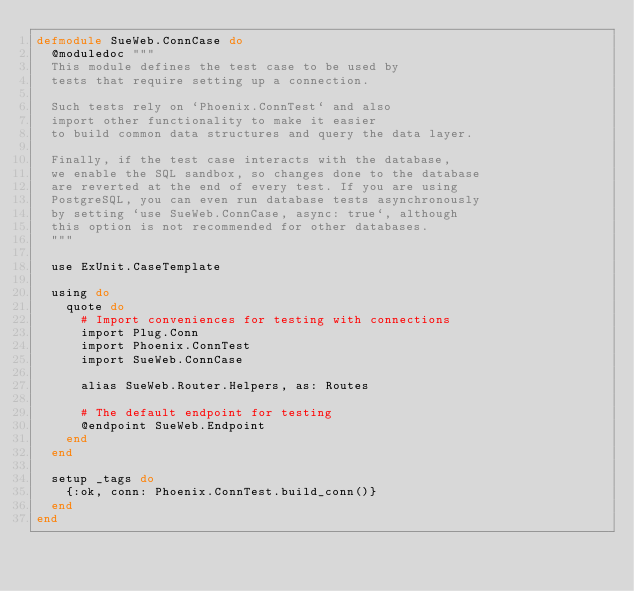Convert code to text. <code><loc_0><loc_0><loc_500><loc_500><_Elixir_>defmodule SueWeb.ConnCase do
  @moduledoc """
  This module defines the test case to be used by
  tests that require setting up a connection.

  Such tests rely on `Phoenix.ConnTest` and also
  import other functionality to make it easier
  to build common data structures and query the data layer.

  Finally, if the test case interacts with the database,
  we enable the SQL sandbox, so changes done to the database
  are reverted at the end of every test. If you are using
  PostgreSQL, you can even run database tests asynchronously
  by setting `use SueWeb.ConnCase, async: true`, although
  this option is not recommended for other databases.
  """

  use ExUnit.CaseTemplate

  using do
    quote do
      # Import conveniences for testing with connections
      import Plug.Conn
      import Phoenix.ConnTest
      import SueWeb.ConnCase

      alias SueWeb.Router.Helpers, as: Routes

      # The default endpoint for testing
      @endpoint SueWeb.Endpoint
    end
  end

  setup _tags do
    {:ok, conn: Phoenix.ConnTest.build_conn()}
  end
end
</code> 